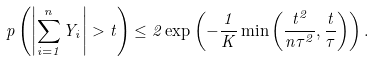<formula> <loc_0><loc_0><loc_500><loc_500>\ p \left ( \left | \sum _ { i = 1 } ^ { n } Y _ { i } \right | > t \right ) \leq 2 \exp \left ( - \frac { 1 } { K } \min \left ( \frac { t ^ { 2 } } { n \tau ^ { 2 } } , \frac { t } { \tau } \right ) \right ) .</formula> 